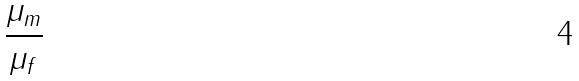<formula> <loc_0><loc_0><loc_500><loc_500>\frac { \mu _ { m } } { \mu _ { f } }</formula> 